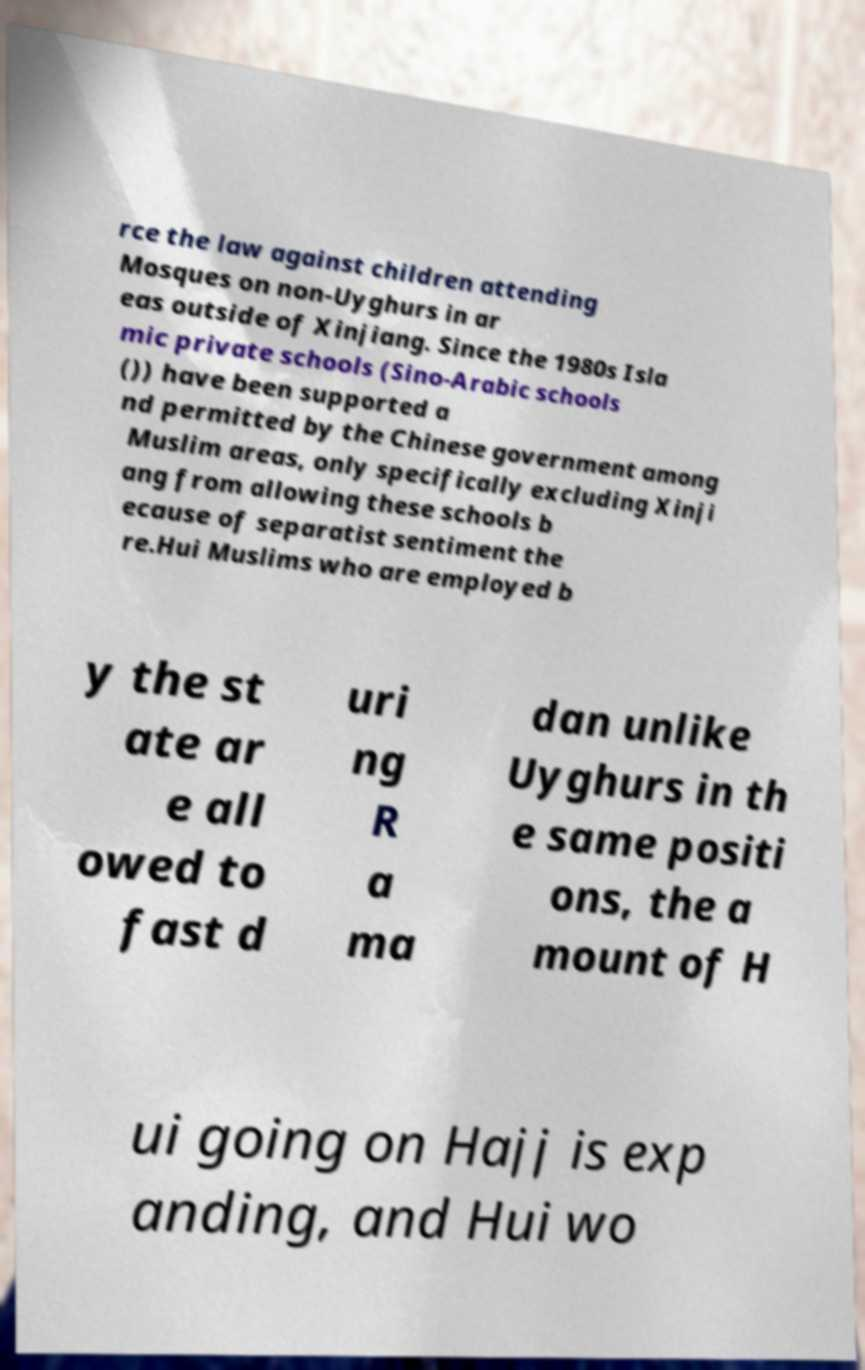Can you accurately transcribe the text from the provided image for me? rce the law against children attending Mosques on non-Uyghurs in ar eas outside of Xinjiang. Since the 1980s Isla mic private schools (Sino-Arabic schools ()) have been supported a nd permitted by the Chinese government among Muslim areas, only specifically excluding Xinji ang from allowing these schools b ecause of separatist sentiment the re.Hui Muslims who are employed b y the st ate ar e all owed to fast d uri ng R a ma dan unlike Uyghurs in th e same positi ons, the a mount of H ui going on Hajj is exp anding, and Hui wo 